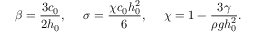Convert formula to latex. <formula><loc_0><loc_0><loc_500><loc_500>\beta = \frac { 3 c _ { 0 } } { 2 h _ { 0 } } , \sigma = \frac { \chi c _ { 0 } h _ { 0 } ^ { 2 } } { 6 } , \chi = 1 - \frac { 3 \gamma } { \rho g h _ { 0 } ^ { 2 } } .</formula> 